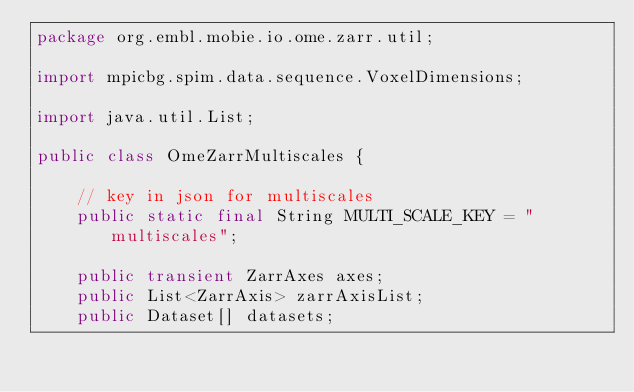<code> <loc_0><loc_0><loc_500><loc_500><_Java_>package org.embl.mobie.io.ome.zarr.util;

import mpicbg.spim.data.sequence.VoxelDimensions;

import java.util.List;

public class OmeZarrMultiscales {

    // key in json for multiscales
    public static final String MULTI_SCALE_KEY = "multiscales";

    public transient ZarrAxes axes;
    public List<ZarrAxis> zarrAxisList;
    public Dataset[] datasets;</code> 